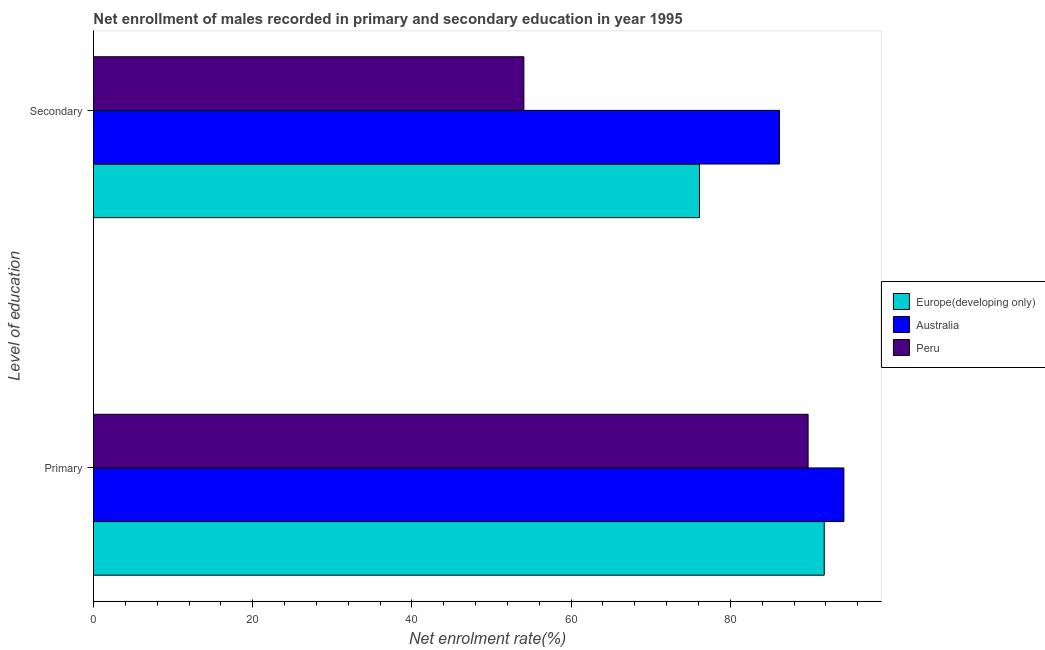How many groups of bars are there?
Offer a very short reply. 2. How many bars are there on the 1st tick from the bottom?
Ensure brevity in your answer.  3. What is the label of the 1st group of bars from the top?
Offer a very short reply. Secondary. What is the enrollment rate in primary education in Australia?
Offer a very short reply. 94.27. Across all countries, what is the maximum enrollment rate in secondary education?
Give a very brief answer. 86.18. Across all countries, what is the minimum enrollment rate in secondary education?
Your answer should be very brief. 54.07. In which country was the enrollment rate in primary education maximum?
Offer a terse response. Australia. In which country was the enrollment rate in secondary education minimum?
Provide a succinct answer. Peru. What is the total enrollment rate in primary education in the graph?
Your answer should be compact. 275.84. What is the difference between the enrollment rate in secondary education in Australia and that in Peru?
Make the answer very short. 32.11. What is the difference between the enrollment rate in primary education in Australia and the enrollment rate in secondary education in Europe(developing only)?
Your answer should be very brief. 18.14. What is the average enrollment rate in secondary education per country?
Keep it short and to the point. 72.12. What is the difference between the enrollment rate in secondary education and enrollment rate in primary education in Australia?
Give a very brief answer. -8.09. In how many countries, is the enrollment rate in secondary education greater than 4 %?
Offer a terse response. 3. What is the ratio of the enrollment rate in secondary education in Australia to that in Peru?
Provide a succinct answer. 1.59. Is the enrollment rate in primary education in Peru less than that in Australia?
Make the answer very short. Yes. What does the 2nd bar from the top in Primary represents?
Provide a succinct answer. Australia. How many bars are there?
Your answer should be very brief. 6. Are all the bars in the graph horizontal?
Make the answer very short. Yes. How many countries are there in the graph?
Keep it short and to the point. 3. Are the values on the major ticks of X-axis written in scientific E-notation?
Your answer should be very brief. No. Where does the legend appear in the graph?
Offer a very short reply. Center right. What is the title of the graph?
Keep it short and to the point. Net enrollment of males recorded in primary and secondary education in year 1995. Does "Azerbaijan" appear as one of the legend labels in the graph?
Keep it short and to the point. No. What is the label or title of the X-axis?
Provide a short and direct response. Net enrolment rate(%). What is the label or title of the Y-axis?
Make the answer very short. Level of education. What is the Net enrolment rate(%) in Europe(developing only) in Primary?
Make the answer very short. 91.8. What is the Net enrolment rate(%) of Australia in Primary?
Offer a very short reply. 94.27. What is the Net enrolment rate(%) in Peru in Primary?
Provide a short and direct response. 89.77. What is the Net enrolment rate(%) in Europe(developing only) in Secondary?
Provide a short and direct response. 76.13. What is the Net enrolment rate(%) in Australia in Secondary?
Your response must be concise. 86.18. What is the Net enrolment rate(%) of Peru in Secondary?
Provide a succinct answer. 54.07. Across all Level of education, what is the maximum Net enrolment rate(%) in Europe(developing only)?
Provide a succinct answer. 91.8. Across all Level of education, what is the maximum Net enrolment rate(%) in Australia?
Keep it short and to the point. 94.27. Across all Level of education, what is the maximum Net enrolment rate(%) in Peru?
Make the answer very short. 89.77. Across all Level of education, what is the minimum Net enrolment rate(%) of Europe(developing only)?
Ensure brevity in your answer.  76.13. Across all Level of education, what is the minimum Net enrolment rate(%) in Australia?
Provide a short and direct response. 86.18. Across all Level of education, what is the minimum Net enrolment rate(%) in Peru?
Your answer should be compact. 54.07. What is the total Net enrolment rate(%) in Europe(developing only) in the graph?
Offer a terse response. 167.93. What is the total Net enrolment rate(%) in Australia in the graph?
Offer a terse response. 180.44. What is the total Net enrolment rate(%) in Peru in the graph?
Provide a succinct answer. 143.84. What is the difference between the Net enrolment rate(%) of Europe(developing only) in Primary and that in Secondary?
Your answer should be compact. 15.67. What is the difference between the Net enrolment rate(%) of Australia in Primary and that in Secondary?
Ensure brevity in your answer.  8.09. What is the difference between the Net enrolment rate(%) in Peru in Primary and that in Secondary?
Offer a terse response. 35.7. What is the difference between the Net enrolment rate(%) of Europe(developing only) in Primary and the Net enrolment rate(%) of Australia in Secondary?
Keep it short and to the point. 5.62. What is the difference between the Net enrolment rate(%) in Europe(developing only) in Primary and the Net enrolment rate(%) in Peru in Secondary?
Offer a very short reply. 37.73. What is the difference between the Net enrolment rate(%) of Australia in Primary and the Net enrolment rate(%) of Peru in Secondary?
Provide a short and direct response. 40.2. What is the average Net enrolment rate(%) of Europe(developing only) per Level of education?
Provide a succinct answer. 83.96. What is the average Net enrolment rate(%) in Australia per Level of education?
Ensure brevity in your answer.  90.22. What is the average Net enrolment rate(%) in Peru per Level of education?
Offer a terse response. 71.92. What is the difference between the Net enrolment rate(%) in Europe(developing only) and Net enrolment rate(%) in Australia in Primary?
Provide a succinct answer. -2.47. What is the difference between the Net enrolment rate(%) of Europe(developing only) and Net enrolment rate(%) of Peru in Primary?
Keep it short and to the point. 2.03. What is the difference between the Net enrolment rate(%) of Australia and Net enrolment rate(%) of Peru in Primary?
Your answer should be very brief. 4.5. What is the difference between the Net enrolment rate(%) in Europe(developing only) and Net enrolment rate(%) in Australia in Secondary?
Your response must be concise. -10.05. What is the difference between the Net enrolment rate(%) of Europe(developing only) and Net enrolment rate(%) of Peru in Secondary?
Give a very brief answer. 22.06. What is the difference between the Net enrolment rate(%) in Australia and Net enrolment rate(%) in Peru in Secondary?
Provide a short and direct response. 32.11. What is the ratio of the Net enrolment rate(%) in Europe(developing only) in Primary to that in Secondary?
Provide a succinct answer. 1.21. What is the ratio of the Net enrolment rate(%) in Australia in Primary to that in Secondary?
Provide a succinct answer. 1.09. What is the ratio of the Net enrolment rate(%) in Peru in Primary to that in Secondary?
Offer a very short reply. 1.66. What is the difference between the highest and the second highest Net enrolment rate(%) in Europe(developing only)?
Provide a short and direct response. 15.67. What is the difference between the highest and the second highest Net enrolment rate(%) in Australia?
Ensure brevity in your answer.  8.09. What is the difference between the highest and the second highest Net enrolment rate(%) in Peru?
Provide a short and direct response. 35.7. What is the difference between the highest and the lowest Net enrolment rate(%) of Europe(developing only)?
Your answer should be compact. 15.67. What is the difference between the highest and the lowest Net enrolment rate(%) of Australia?
Provide a short and direct response. 8.09. What is the difference between the highest and the lowest Net enrolment rate(%) in Peru?
Your answer should be compact. 35.7. 